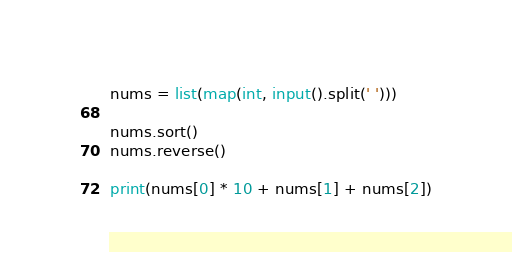Convert code to text. <code><loc_0><loc_0><loc_500><loc_500><_Python_>nums = list(map(int, input().split(' ')))

nums.sort()
nums.reverse()

print(nums[0] * 10 + nums[1] + nums[2])

</code> 